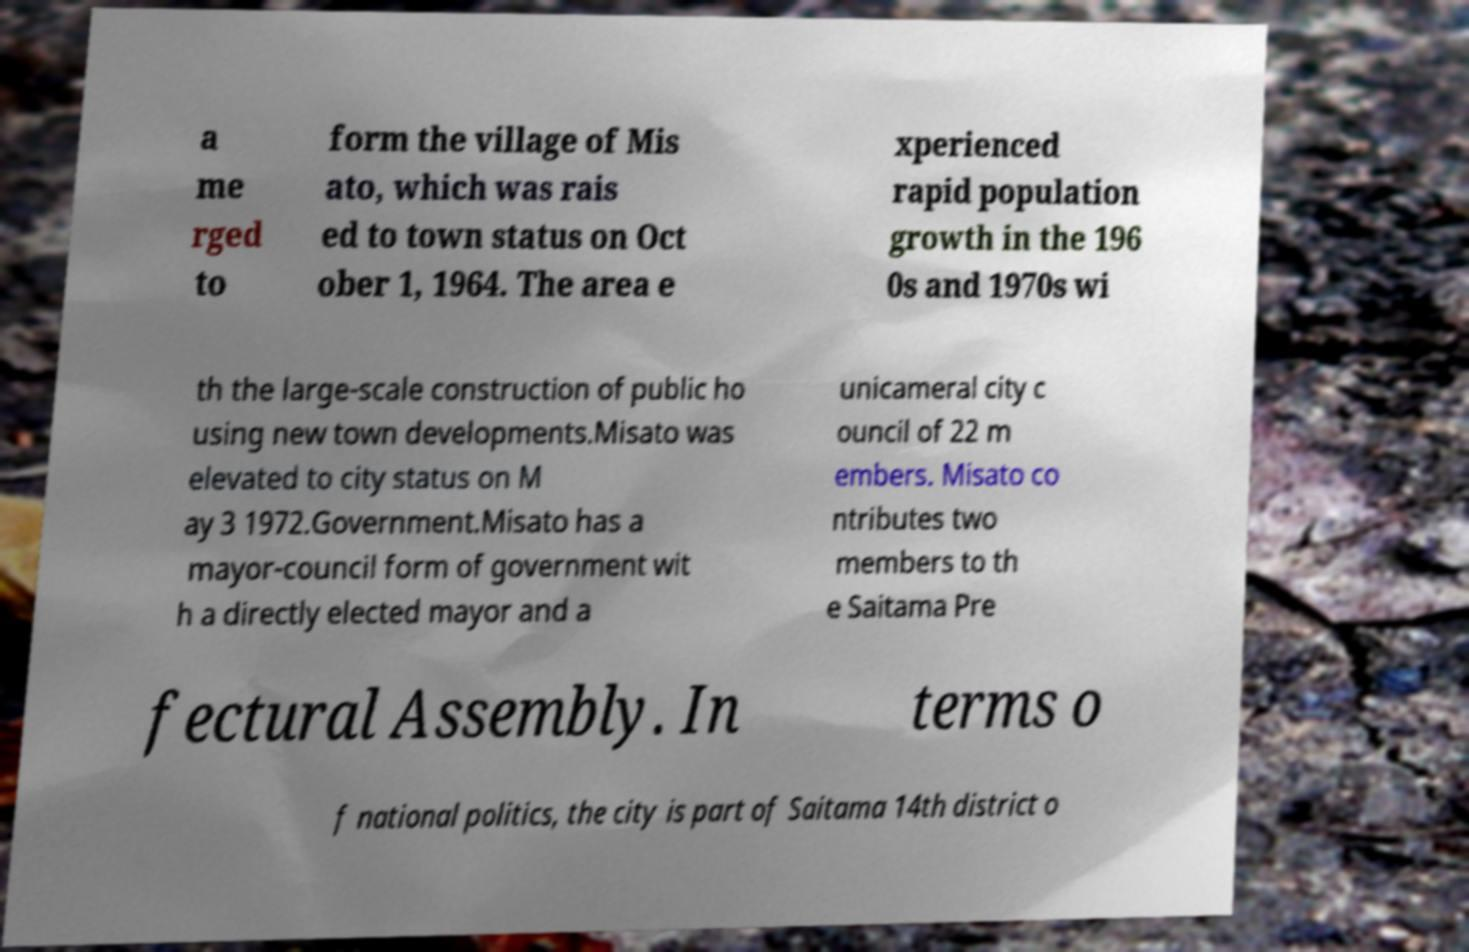Can you read and provide the text displayed in the image?This photo seems to have some interesting text. Can you extract and type it out for me? a me rged to form the village of Mis ato, which was rais ed to town status on Oct ober 1, 1964. The area e xperienced rapid population growth in the 196 0s and 1970s wi th the large-scale construction of public ho using new town developments.Misato was elevated to city status on M ay 3 1972.Government.Misato has a mayor-council form of government wit h a directly elected mayor and a unicameral city c ouncil of 22 m embers. Misato co ntributes two members to th e Saitama Pre fectural Assembly. In terms o f national politics, the city is part of Saitama 14th district o 